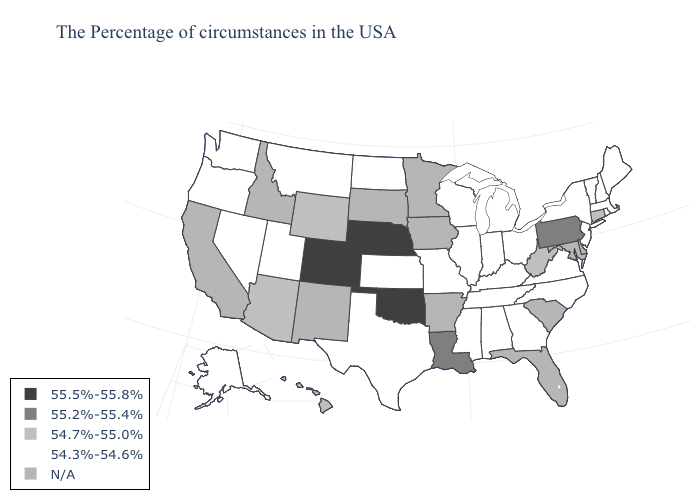Among the states that border Pennsylvania , which have the lowest value?
Quick response, please. New York, New Jersey, Ohio. How many symbols are there in the legend?
Concise answer only. 5. What is the lowest value in states that border Kansas?
Answer briefly. 54.3%-54.6%. Name the states that have a value in the range 55.5%-55.8%?
Be succinct. Nebraska, Oklahoma, Colorado. What is the highest value in the USA?
Keep it brief. 55.5%-55.8%. What is the lowest value in states that border Utah?
Concise answer only. 54.3%-54.6%. What is the value of South Dakota?
Short answer required. N/A. How many symbols are there in the legend?
Answer briefly. 5. Name the states that have a value in the range N/A?
Answer briefly. Delaware, Maryland, South Carolina, Florida, Arkansas, Minnesota, Iowa, South Dakota, New Mexico, Idaho, California. What is the value of Delaware?
Be succinct. N/A. What is the value of Tennessee?
Give a very brief answer. 54.3%-54.6%. Among the states that border Oklahoma , which have the highest value?
Short answer required. Colorado. Name the states that have a value in the range 55.2%-55.4%?
Answer briefly. Pennsylvania, Louisiana. 